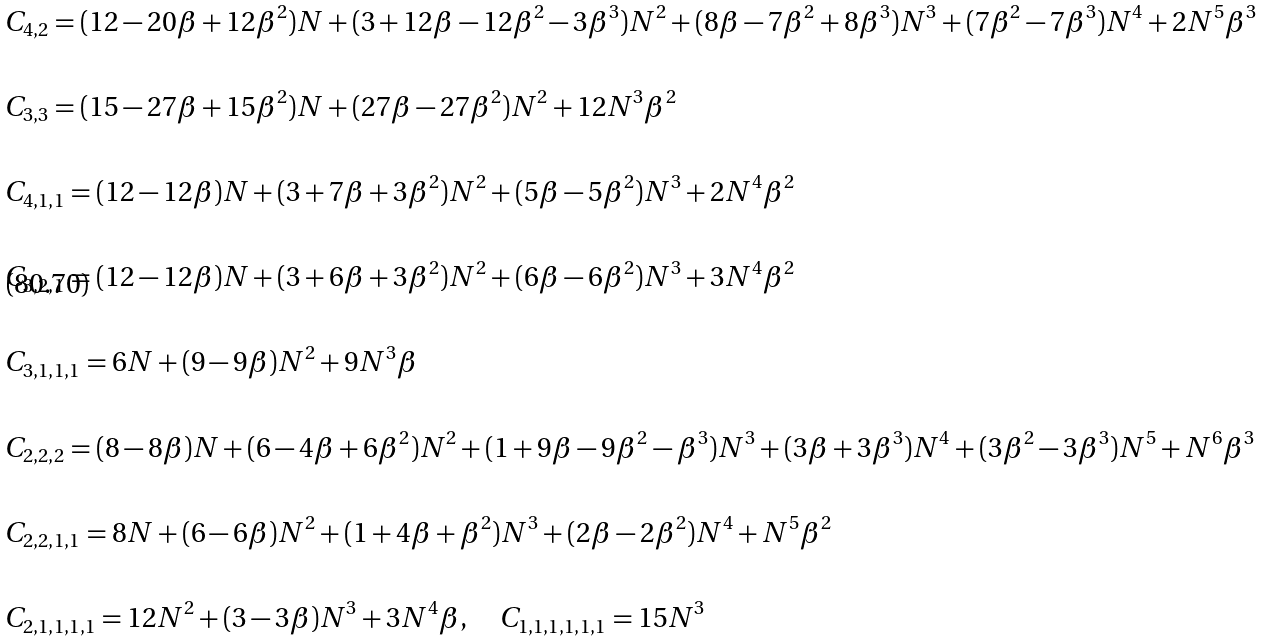<formula> <loc_0><loc_0><loc_500><loc_500>& C _ { 4 , 2 } = ( 1 2 - 2 0 \beta + 1 2 \beta ^ { 2 } ) N + ( 3 + 1 2 \beta - 1 2 \beta ^ { 2 } - 3 \beta ^ { 3 } ) N ^ { 2 } + ( 8 \beta - 7 \beta ^ { 2 } + 8 \beta ^ { 3 } ) N ^ { 3 } + ( 7 \beta ^ { 2 } - 7 \beta ^ { 3 } ) N ^ { 4 } + 2 N ^ { 5 } \beta ^ { 3 } \\ & \\ & C _ { 3 , 3 } = ( 1 5 - 2 7 \beta + 1 5 \beta ^ { 2 } ) N + ( 2 7 \beta - 2 7 \beta ^ { 2 } ) N ^ { 2 } + 1 2 N ^ { 3 } \beta ^ { 2 } \\ & \\ & C _ { 4 , 1 , 1 } = ( 1 2 - 1 2 \beta ) N + ( 3 + 7 \beta + 3 \beta ^ { 2 } ) N ^ { 2 } + ( 5 \beta - 5 \beta ^ { 2 } ) N ^ { 3 } + 2 N ^ { 4 } \beta ^ { 2 } \\ & \\ & C _ { 3 , 2 , 1 } = ( 1 2 - 1 2 \beta ) N + ( 3 + 6 \beta + 3 \beta ^ { 2 } ) N ^ { 2 } + ( 6 \beta - 6 \beta ^ { 2 } ) N ^ { 3 } + 3 N ^ { 4 } \beta ^ { 2 } \\ & \\ & C _ { 3 , 1 , 1 , 1 } = 6 N + ( 9 - 9 \beta ) N ^ { 2 } + 9 N ^ { 3 } \beta \\ & \\ & C _ { 2 , 2 , 2 } = ( 8 - 8 \beta ) N + ( 6 - 4 \beta + 6 \beta ^ { 2 } ) N ^ { 2 } + ( 1 + 9 \beta - 9 \beta ^ { 2 } - \beta ^ { 3 } ) N ^ { 3 } + ( 3 \beta + 3 \beta ^ { 3 } ) N ^ { 4 } + ( 3 \beta ^ { 2 } - 3 \beta ^ { 3 } ) N ^ { 5 } + N ^ { 6 } \beta ^ { 3 } \\ & \\ & C _ { 2 , 2 , 1 , 1 } = 8 N + ( 6 - 6 \beta ) N ^ { 2 } + ( 1 + 4 \beta + \beta ^ { 2 } ) N ^ { 3 } + ( 2 \beta - 2 \beta ^ { 2 } ) N ^ { 4 } + N ^ { 5 } \beta ^ { 2 } \\ & \\ & C _ { 2 , 1 , 1 , 1 , 1 } = 1 2 N ^ { 2 } + ( 3 - 3 \beta ) N ^ { 3 } + 3 N ^ { 4 } \beta , \quad C _ { 1 , 1 , 1 , 1 , 1 , 1 } = 1 5 N ^ { 3 }</formula> 